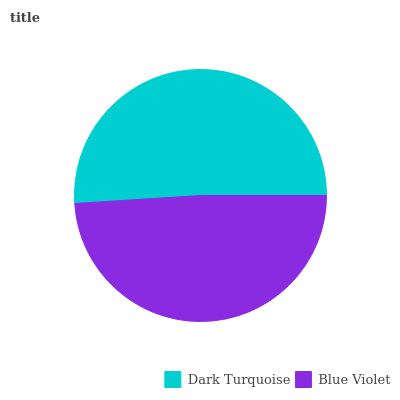Is Blue Violet the minimum?
Answer yes or no. Yes. Is Dark Turquoise the maximum?
Answer yes or no. Yes. Is Blue Violet the maximum?
Answer yes or no. No. Is Dark Turquoise greater than Blue Violet?
Answer yes or no. Yes. Is Blue Violet less than Dark Turquoise?
Answer yes or no. Yes. Is Blue Violet greater than Dark Turquoise?
Answer yes or no. No. Is Dark Turquoise less than Blue Violet?
Answer yes or no. No. Is Dark Turquoise the high median?
Answer yes or no. Yes. Is Blue Violet the low median?
Answer yes or no. Yes. Is Blue Violet the high median?
Answer yes or no. No. Is Dark Turquoise the low median?
Answer yes or no. No. 